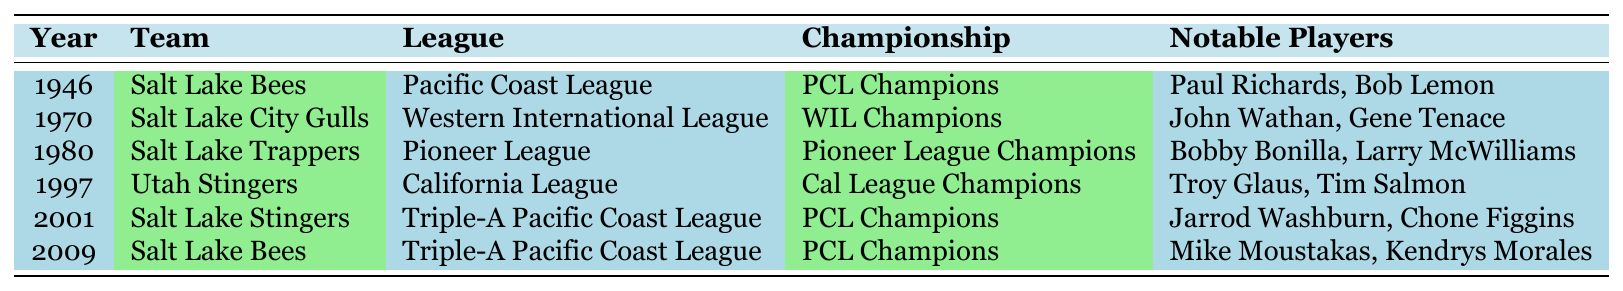What year did the Salt Lake Bees win their first championship? By looking at the table, the first entry for the Salt Lake Bees is in 1946. Hence, they won their first championship that year.
Answer: 1946 How many different teams have won championships in Salt Lake City? Counting the unique team names listed in the table, we see six different teams: Salt Lake Bees, Salt Lake City Gulls, Salt Lake Trappers, Utah Stingers, Salt Lake Stingers, and Salt Lake Bees again. Therefore, there are five unique teams.
Answer: 5 Which team won the championship in 1997? Referring directly to the table, it shows that the Utah Stingers won the championship in that year.
Answer: Utah Stingers Who were the notable players for the Salt Lake Trappers? The table indicates that the notable players for the Salt Lake Trappers are Bobby Bonilla and Larry McWilliams.
Answer: Bobby Bonilla, Larry McWilliams How many times have the Salt Lake Bees won the championship? The table shows two separate years for wins by the Salt Lake Bees (1946 and 2009). Therefore, they have won the championship twice.
Answer: 2 Which league did the Salt Lake City Gulls compete in when they won their championship? From the table, the Salt Lake City Gulls competed in the Western International League when they won their championship in 1970.
Answer: Western International League What is the latest championship win recorded in the table? The most recent entry in the table is from the year 2009, which indicates the latest championship win by the Salt Lake Bees.
Answer: 2009 Which team won the championship in the same league as the Salt Lake Bees and in what year? The Salt Lake Bees won in the Pacific Coast League in 1946 and again in 2009, and the Salt Lake Stingers also won in the Pacific Coast League in 2001, making that the same league with a different team.
Answer: 2001 How many championship wins were recorded in the 2000s? The 2000s in the table shows two championships (2001 and 2009). Summing them gives a total of two championships in that decade.
Answer: 2 Were there any championships won by teams in the Pioneer League? The table shows that the Salt Lake Trappers won a championship in the Pioneer League in 1980, which confirms there was a championship win in that league.
Answer: Yes 